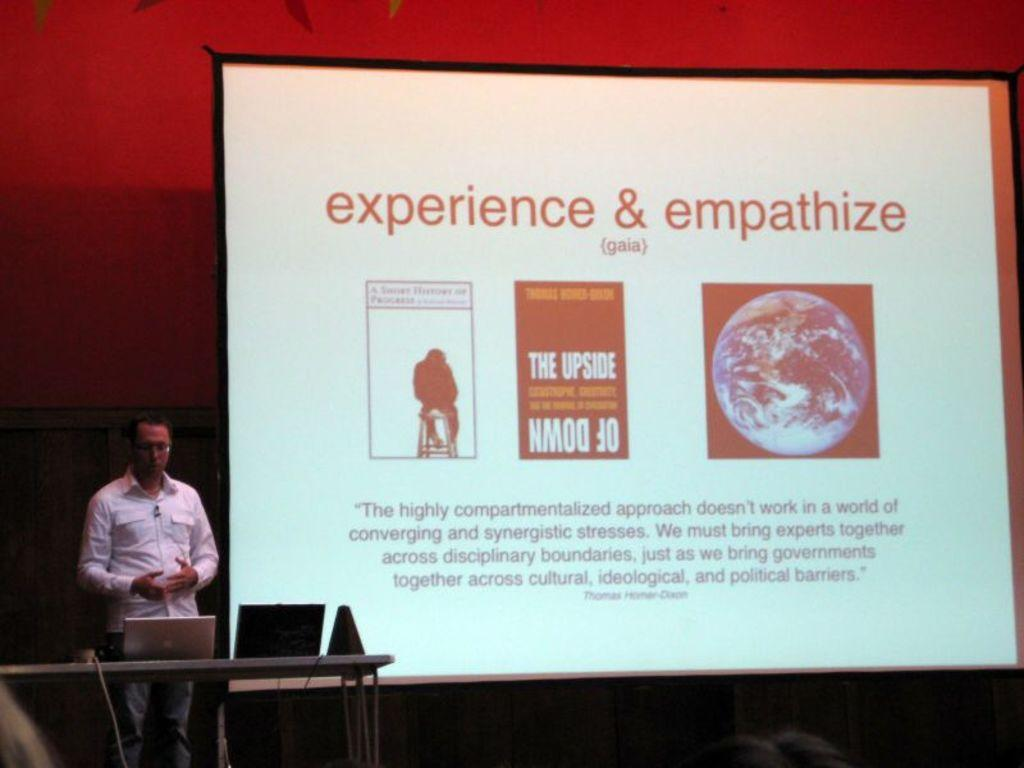<image>
Give a short and clear explanation of the subsequent image. A computer screen that says "experience & empathize" 